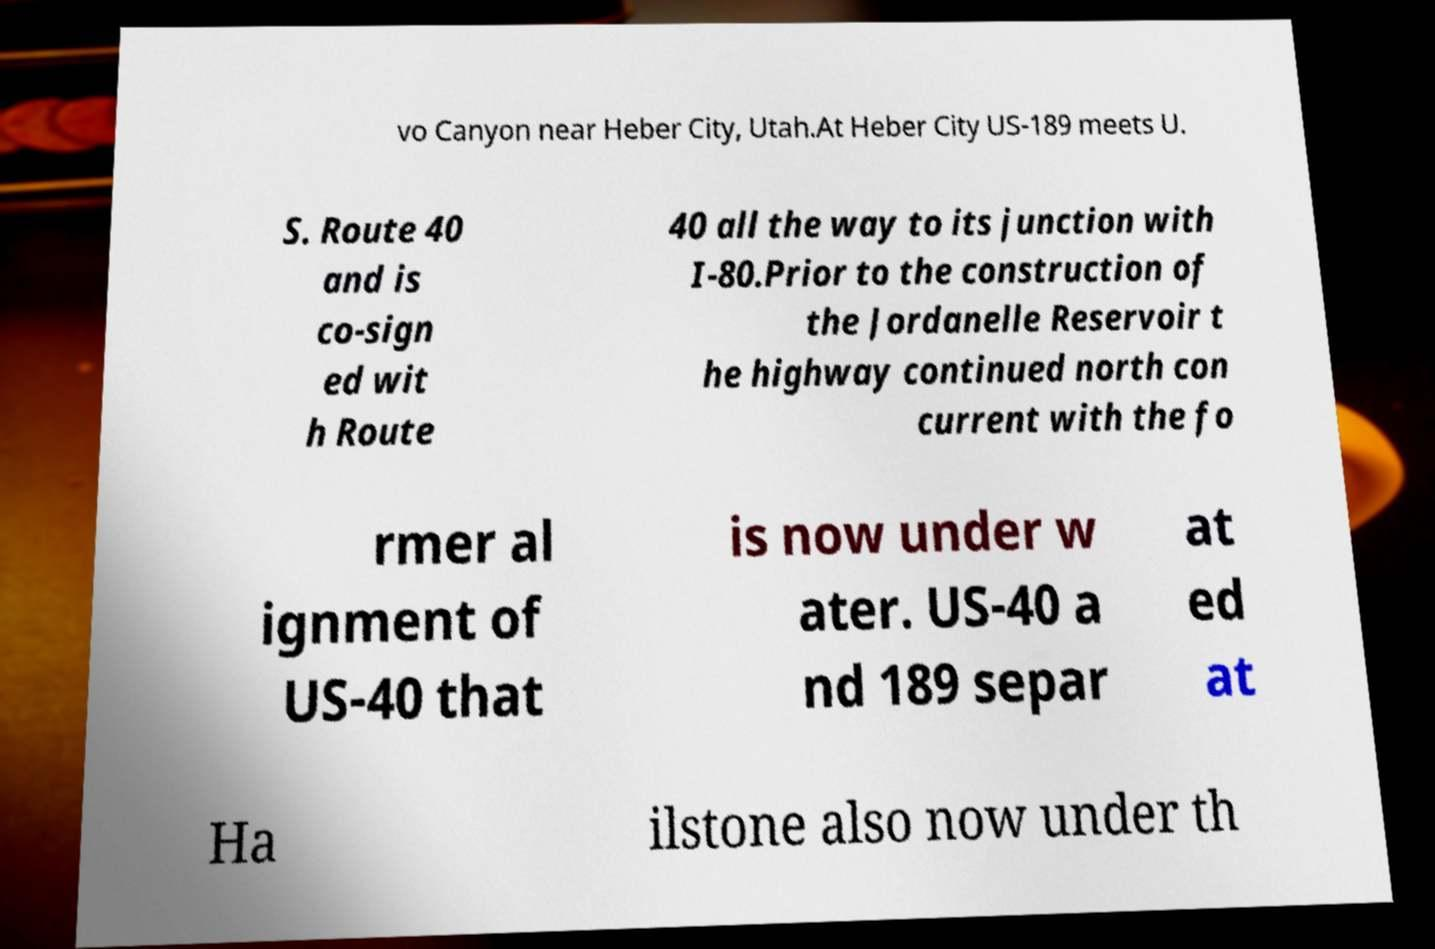What messages or text are displayed in this image? I need them in a readable, typed format. vo Canyon near Heber City, Utah.At Heber City US-189 meets U. S. Route 40 and is co-sign ed wit h Route 40 all the way to its junction with I-80.Prior to the construction of the Jordanelle Reservoir t he highway continued north con current with the fo rmer al ignment of US-40 that is now under w ater. US-40 a nd 189 separ at ed at Ha ilstone also now under th 